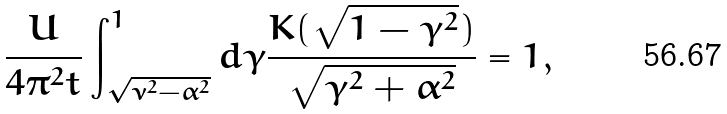Convert formula to latex. <formula><loc_0><loc_0><loc_500><loc_500>\frac { U } { 4 \pi ^ { 2 } t } \int ^ { 1 } _ { \sqrt { \nu ^ { 2 } - \alpha ^ { 2 } } } d \gamma \frac { K ( \sqrt { 1 - \gamma ^ { 2 } } ) } { \sqrt { \gamma ^ { 2 } + \alpha ^ { 2 } } } = 1 ,</formula> 